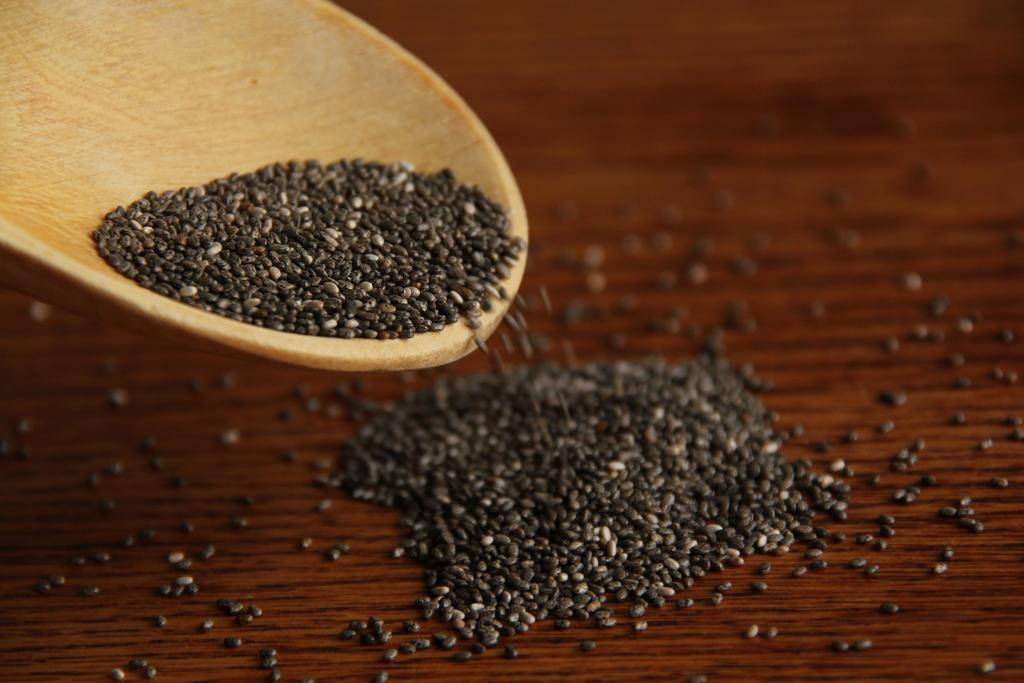What type of objects are present in the image? There are seeds in the image. What colors are the seeds? The seeds are in black and white colors. Where are some of the seeds located? Some seeds are in a wooden object, and some are on a brown color surface. How do the hands interact with the seeds in the image? There are no hands present in the image, so it is not possible to describe any interaction between hands and seeds. 